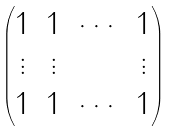<formula> <loc_0><loc_0><loc_500><loc_500>\begin{pmatrix} 1 & 1 & \cdots & 1 \\ \vdots & \vdots & & \vdots \\ 1 & 1 & \cdots & 1 \end{pmatrix}</formula> 